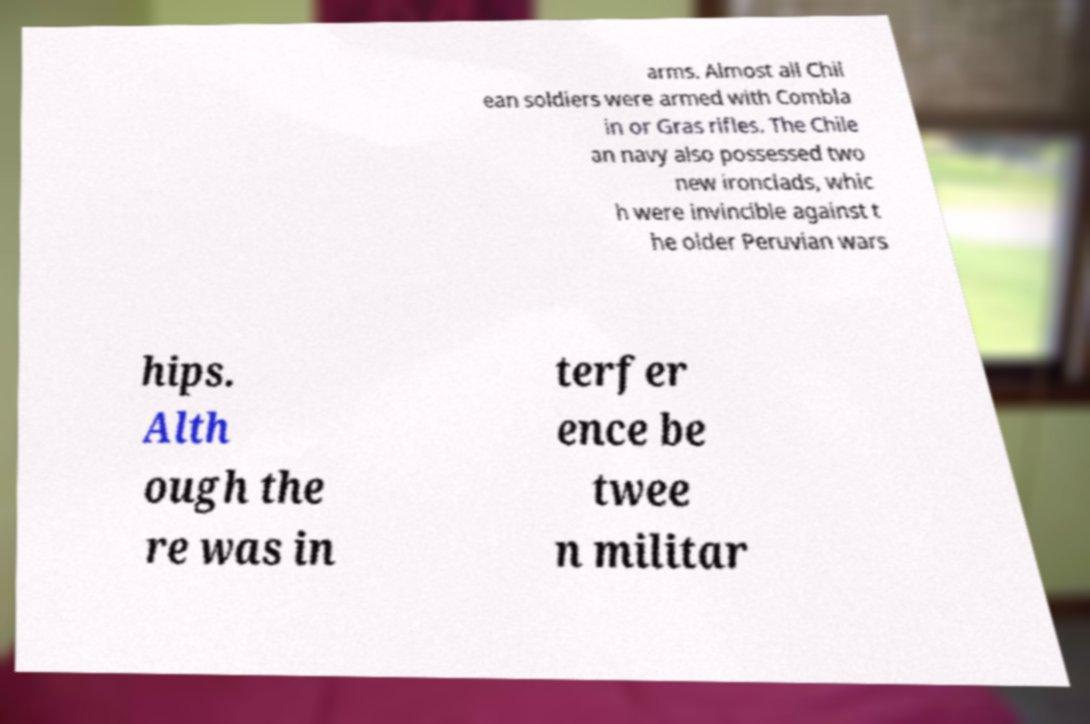Can you read and provide the text displayed in the image?This photo seems to have some interesting text. Can you extract and type it out for me? arms. Almost all Chil ean soldiers were armed with Combla in or Gras rifles. The Chile an navy also possessed two new ironclads, whic h were invincible against t he older Peruvian wars hips. Alth ough the re was in terfer ence be twee n militar 